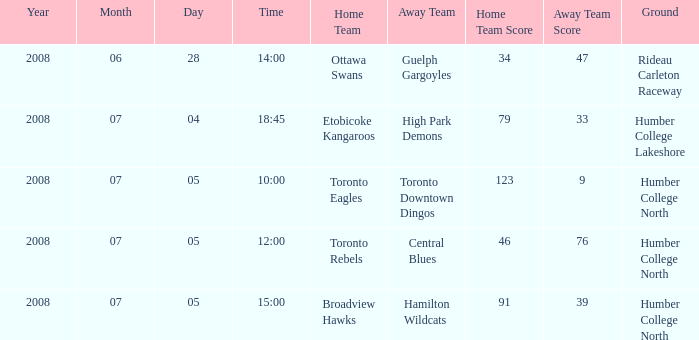What is the Away with a Time that is 14:00? Guelph Gargoyles. 